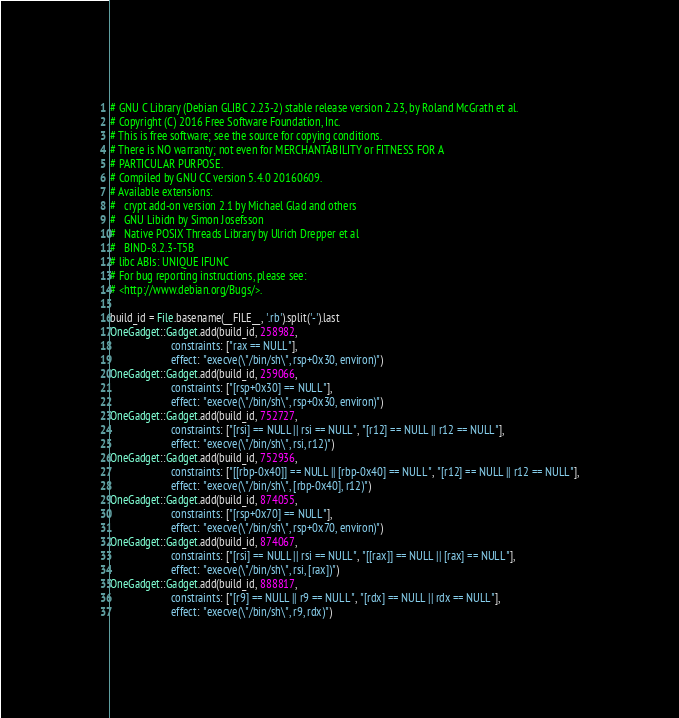<code> <loc_0><loc_0><loc_500><loc_500><_Ruby_># GNU C Library (Debian GLIBC 2.23-2) stable release version 2.23, by Roland McGrath et al.
# Copyright (C) 2016 Free Software Foundation, Inc.
# This is free software; see the source for copying conditions.
# There is NO warranty; not even for MERCHANTABILITY or FITNESS FOR A
# PARTICULAR PURPOSE.
# Compiled by GNU CC version 5.4.0 20160609.
# Available extensions:
# 	crypt add-on version 2.1 by Michael Glad and others
# 	GNU Libidn by Simon Josefsson
# 	Native POSIX Threads Library by Ulrich Drepper et al
# 	BIND-8.2.3-T5B
# libc ABIs: UNIQUE IFUNC
# For bug reporting instructions, please see:
# <http://www.debian.org/Bugs/>.

build_id = File.basename(__FILE__, '.rb').split('-').last
OneGadget::Gadget.add(build_id, 258982,
                      constraints: ["rax == NULL"],
                      effect: "execve(\"/bin/sh\", rsp+0x30, environ)")
OneGadget::Gadget.add(build_id, 259066,
                      constraints: ["[rsp+0x30] == NULL"],
                      effect: "execve(\"/bin/sh\", rsp+0x30, environ)")
OneGadget::Gadget.add(build_id, 752727,
                      constraints: ["[rsi] == NULL || rsi == NULL", "[r12] == NULL || r12 == NULL"],
                      effect: "execve(\"/bin/sh\", rsi, r12)")
OneGadget::Gadget.add(build_id, 752936,
                      constraints: ["[[rbp-0x40]] == NULL || [rbp-0x40] == NULL", "[r12] == NULL || r12 == NULL"],
                      effect: "execve(\"/bin/sh\", [rbp-0x40], r12)")
OneGadget::Gadget.add(build_id, 874055,
                      constraints: ["[rsp+0x70] == NULL"],
                      effect: "execve(\"/bin/sh\", rsp+0x70, environ)")
OneGadget::Gadget.add(build_id, 874067,
                      constraints: ["[rsi] == NULL || rsi == NULL", "[[rax]] == NULL || [rax] == NULL"],
                      effect: "execve(\"/bin/sh\", rsi, [rax])")
OneGadget::Gadget.add(build_id, 888817,
                      constraints: ["[r9] == NULL || r9 == NULL", "[rdx] == NULL || rdx == NULL"],
                      effect: "execve(\"/bin/sh\", r9, rdx)")

</code> 